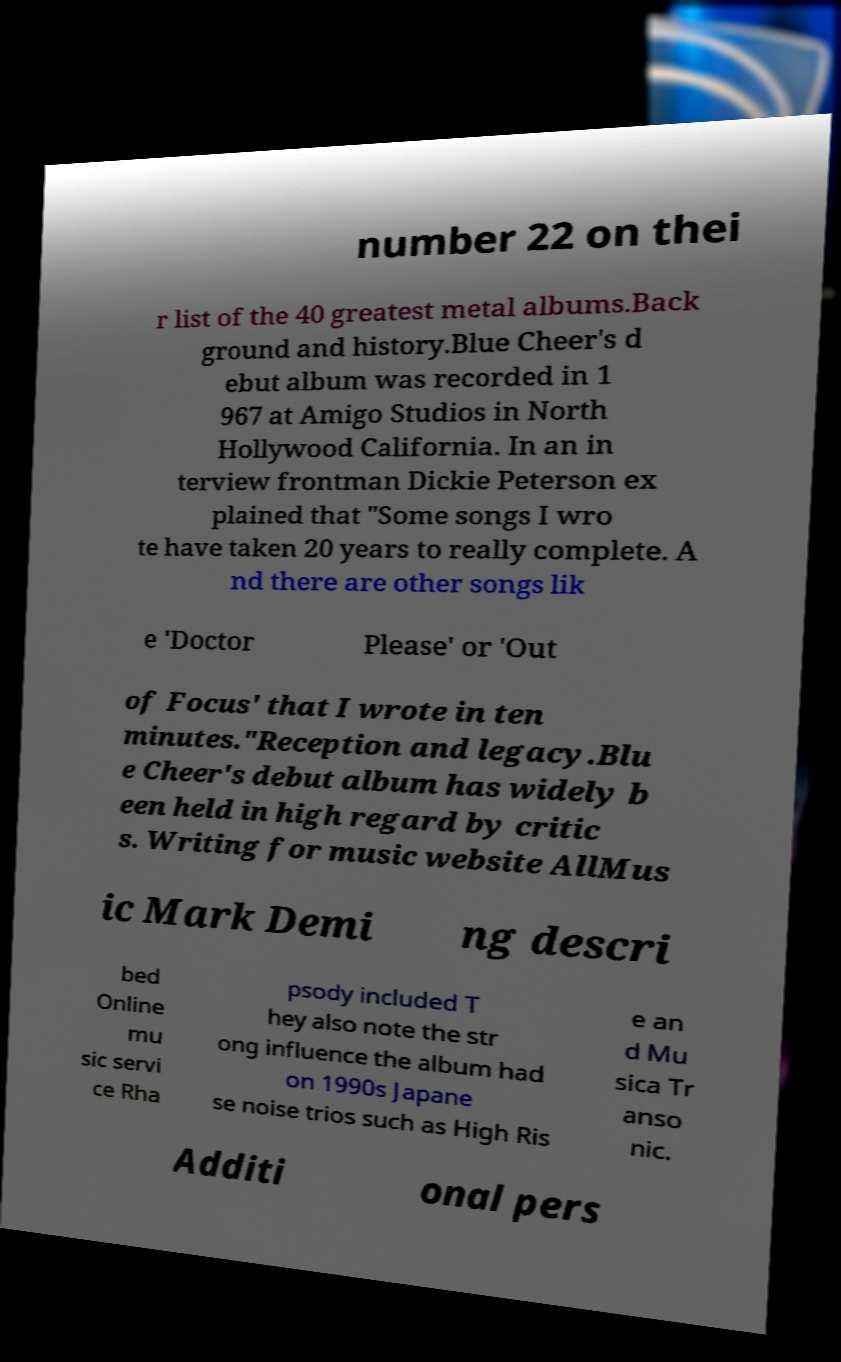I need the written content from this picture converted into text. Can you do that? number 22 on thei r list of the 40 greatest metal albums.Back ground and history.Blue Cheer's d ebut album was recorded in 1 967 at Amigo Studios in North Hollywood California. In an in terview frontman Dickie Peterson ex plained that "Some songs I wro te have taken 20 years to really complete. A nd there are other songs lik e 'Doctor Please' or 'Out of Focus' that I wrote in ten minutes."Reception and legacy.Blu e Cheer's debut album has widely b een held in high regard by critic s. Writing for music website AllMus ic Mark Demi ng descri bed Online mu sic servi ce Rha psody included T hey also note the str ong influence the album had on 1990s Japane se noise trios such as High Ris e an d Mu sica Tr anso nic. Additi onal pers 